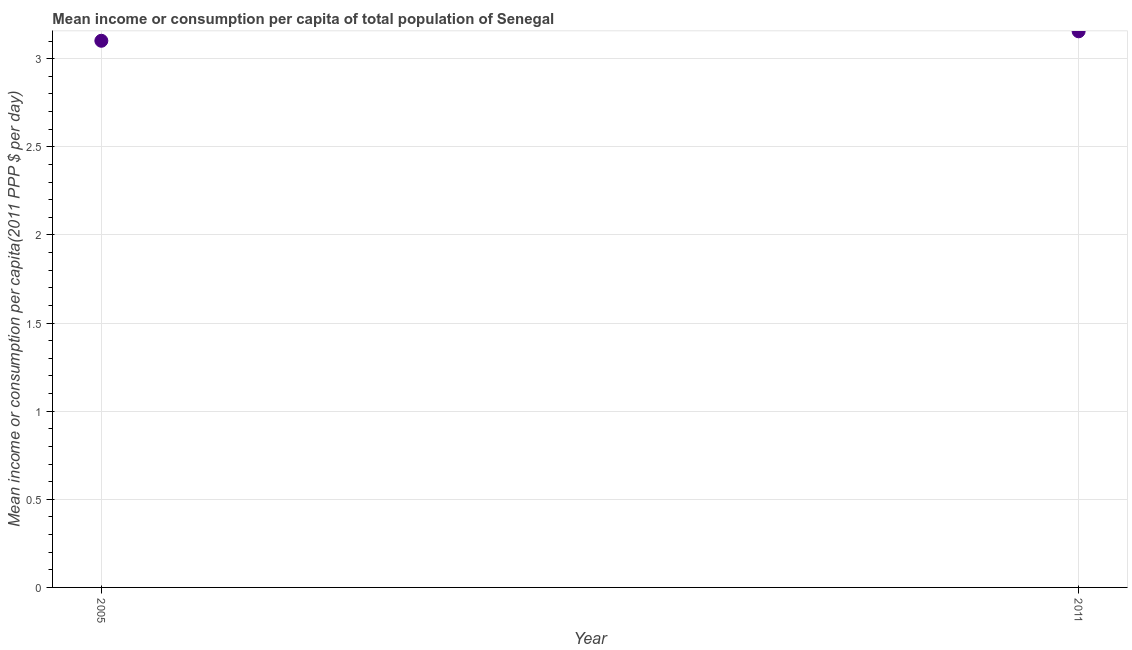What is the mean income or consumption in 2011?
Your answer should be compact. 3.16. Across all years, what is the maximum mean income or consumption?
Your answer should be very brief. 3.16. Across all years, what is the minimum mean income or consumption?
Give a very brief answer. 3.1. In which year was the mean income or consumption maximum?
Your answer should be very brief. 2011. What is the sum of the mean income or consumption?
Give a very brief answer. 6.26. What is the difference between the mean income or consumption in 2005 and 2011?
Keep it short and to the point. -0.05. What is the average mean income or consumption per year?
Your answer should be compact. 3.13. What is the median mean income or consumption?
Offer a very short reply. 3.13. In how many years, is the mean income or consumption greater than 2.5 $?
Ensure brevity in your answer.  2. What is the ratio of the mean income or consumption in 2005 to that in 2011?
Keep it short and to the point. 0.98. Is the mean income or consumption in 2005 less than that in 2011?
Make the answer very short. Yes. In how many years, is the mean income or consumption greater than the average mean income or consumption taken over all years?
Keep it short and to the point. 1. How many dotlines are there?
Make the answer very short. 1. What is the difference between two consecutive major ticks on the Y-axis?
Make the answer very short. 0.5. What is the title of the graph?
Give a very brief answer. Mean income or consumption per capita of total population of Senegal. What is the label or title of the Y-axis?
Provide a succinct answer. Mean income or consumption per capita(2011 PPP $ per day). What is the Mean income or consumption per capita(2011 PPP $ per day) in 2005?
Your response must be concise. 3.1. What is the Mean income or consumption per capita(2011 PPP $ per day) in 2011?
Your answer should be compact. 3.16. What is the difference between the Mean income or consumption per capita(2011 PPP $ per day) in 2005 and 2011?
Provide a short and direct response. -0.05. 